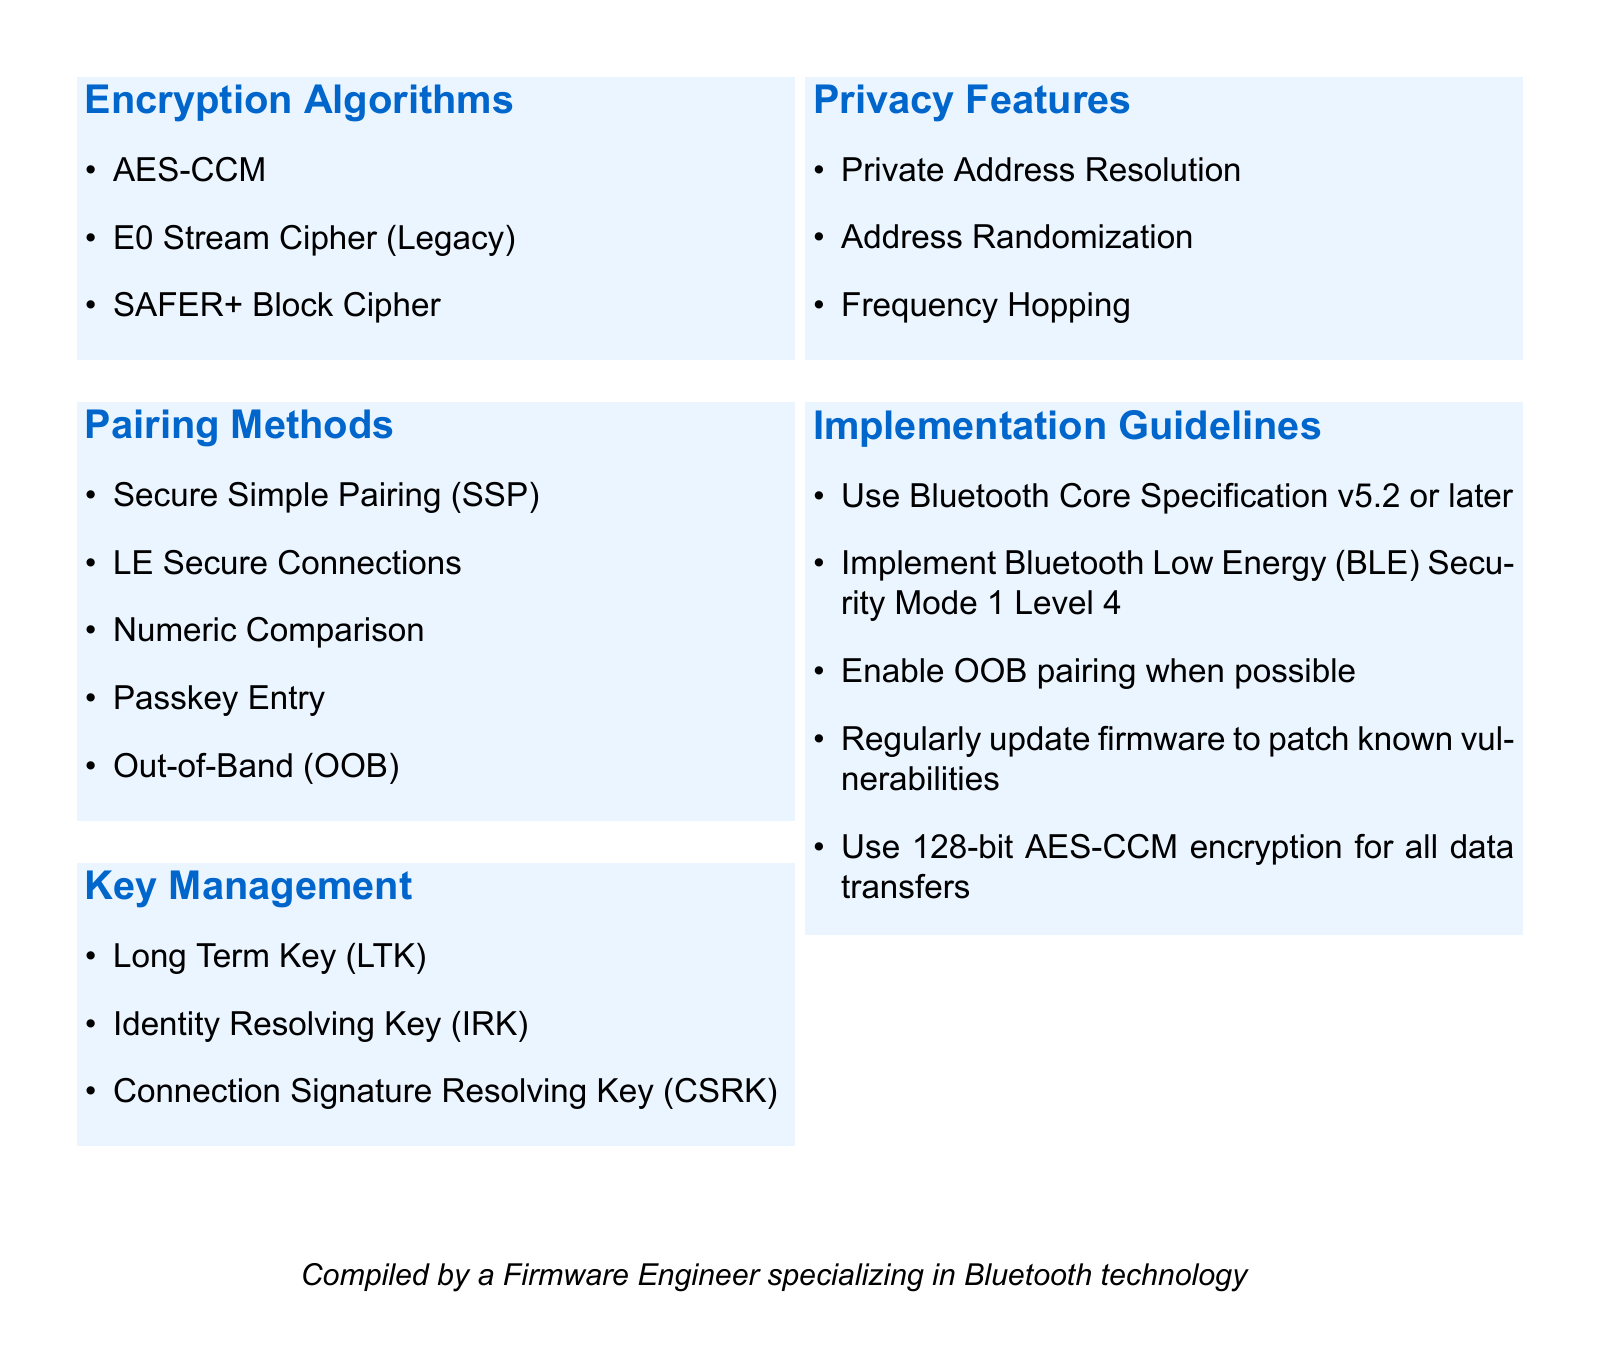What are the encryption algorithms listed? The document lists specific encryption algorithms relevant to Bluetooth technology.
Answer: AES-CCM, E0 Stream Cipher (Legacy), SAFER+ Block Cipher What is the first pairing method mentioned? The document outlines pairing methods, starting with the first one.
Answer: Secure Simple Pairing (SSP) How many key management types are there? The document provides a list of key management types in Bluetooth security.
Answer: Three What privacy feature includes address randomization? The document lists privacy features, and one of them specifically addresses randomization.
Answer: Address Randomization What is recommended for firmware updates? The document provides a guideline regarding the regularity and purpose of firmware updates.
Answer: Regularly update firmware to patch known vulnerabilities What is the required Bluetooth Core Specification version? The document outlines specific guidelines for implementation, including a version requirement.
Answer: v5.2 or later What is the encryption bit length recommended? The document specifies the encryption standard for data transfers in terms of bit length.
Answer: 128-bit What is the last method of pairing mentioned? The document lists various pairing methods, ending with one specific method.
Answer: Out-of-Band (OOB) 